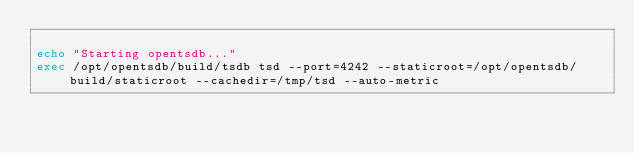Convert code to text. <code><loc_0><loc_0><loc_500><loc_500><_Bash_>
echo "Starting opentsdb..."
exec /opt/opentsdb/build/tsdb tsd --port=4242 --staticroot=/opt/opentsdb/build/staticroot --cachedir=/tmp/tsd --auto-metric


</code> 